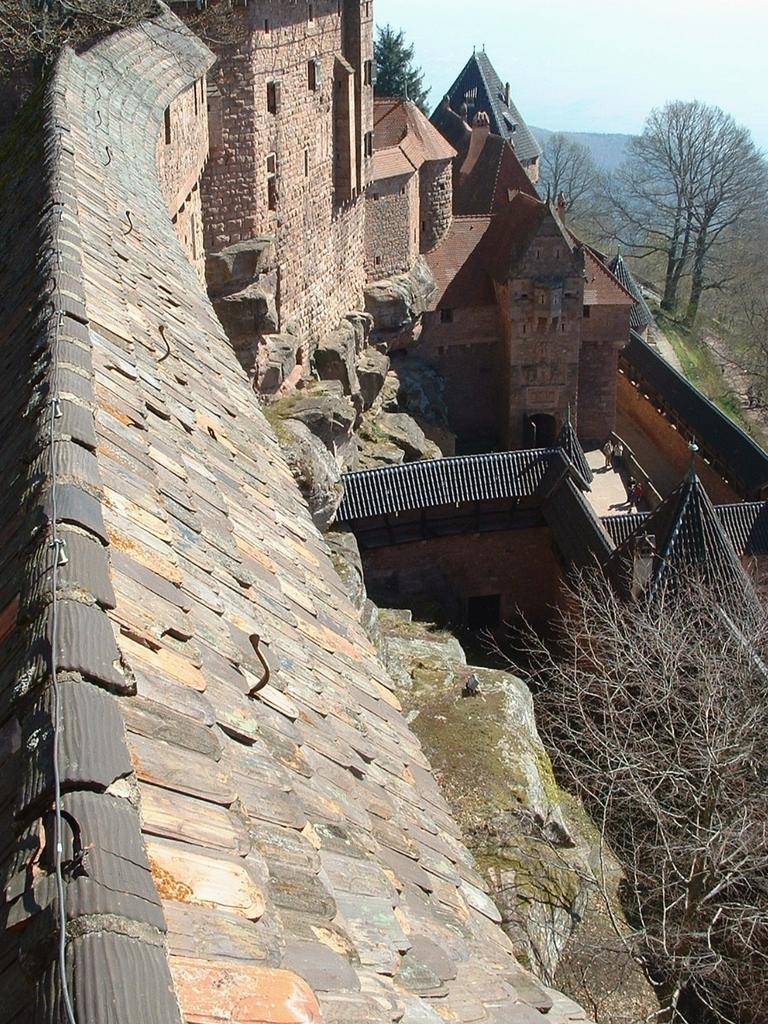Describe this image in one or two sentences. In this image we can see roof, trees, castle, hills and sky. 